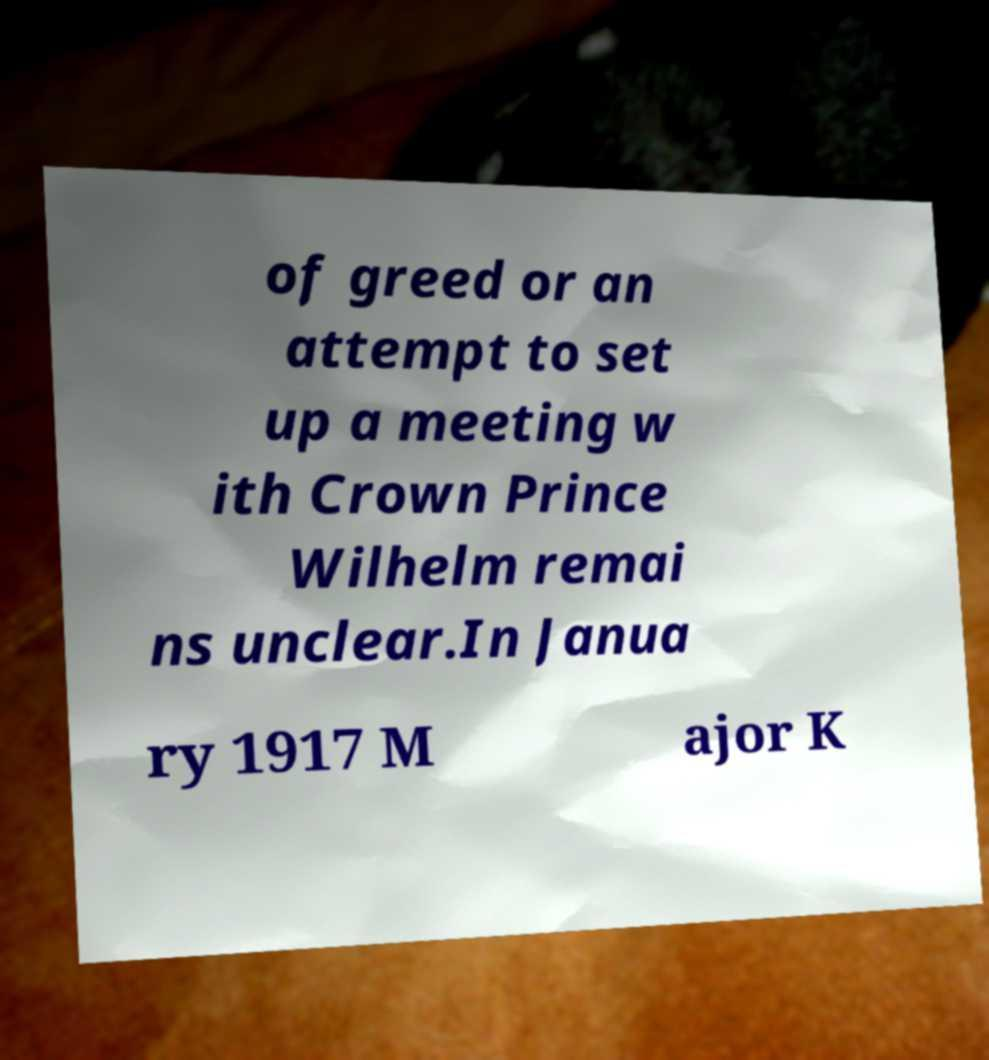Can you accurately transcribe the text from the provided image for me? of greed or an attempt to set up a meeting w ith Crown Prince Wilhelm remai ns unclear.In Janua ry 1917 M ajor K 